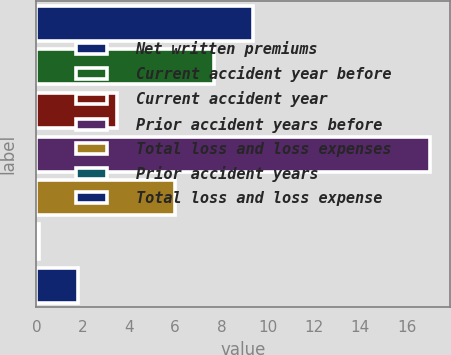<chart> <loc_0><loc_0><loc_500><loc_500><bar_chart><fcel>Net written premiums<fcel>Current accident year before<fcel>Current accident year<fcel>Prior accident years before<fcel>Total loss and loss expenses<fcel>Prior accident years<fcel>Total loss and loss expense<nl><fcel>9.38<fcel>7.69<fcel>3.48<fcel>17<fcel>6<fcel>0.1<fcel>1.79<nl></chart> 